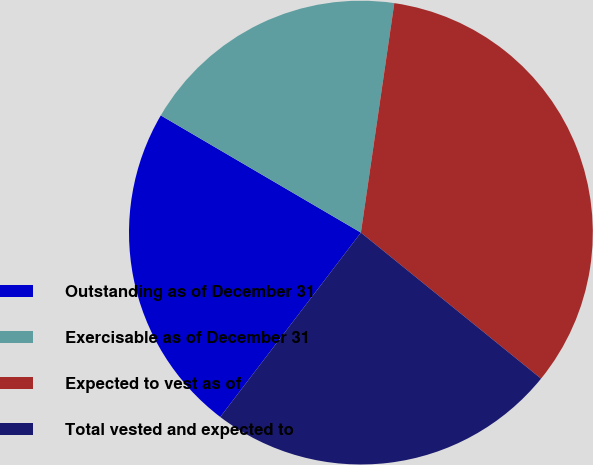Convert chart. <chart><loc_0><loc_0><loc_500><loc_500><pie_chart><fcel>Outstanding as of December 31<fcel>Exercisable as of December 31<fcel>Expected to vest as of<fcel>Total vested and expected to<nl><fcel>23.06%<fcel>18.87%<fcel>33.54%<fcel>24.53%<nl></chart> 